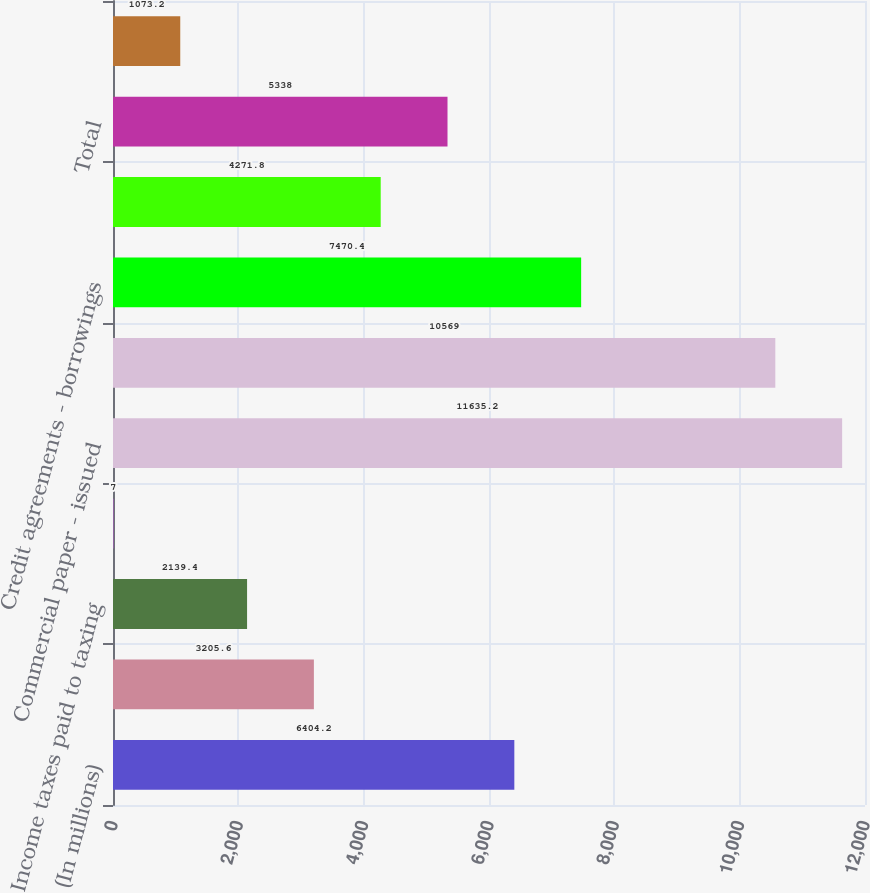Convert chart to OTSL. <chart><loc_0><loc_0><loc_500><loc_500><bar_chart><fcel>(In millions)<fcel>Interest and other financing<fcel>Income taxes paid to taxing<fcel>Income tax settlements paid to<fcel>Commercial paper - issued<fcel>- repayments<fcel>Credit agreements - borrowings<fcel>Ashland credit agreements -<fcel>Total<fcel>Common Stock issued for<nl><fcel>6404.2<fcel>3205.6<fcel>2139.4<fcel>7<fcel>11635.2<fcel>10569<fcel>7470.4<fcel>4271.8<fcel>5338<fcel>1073.2<nl></chart> 